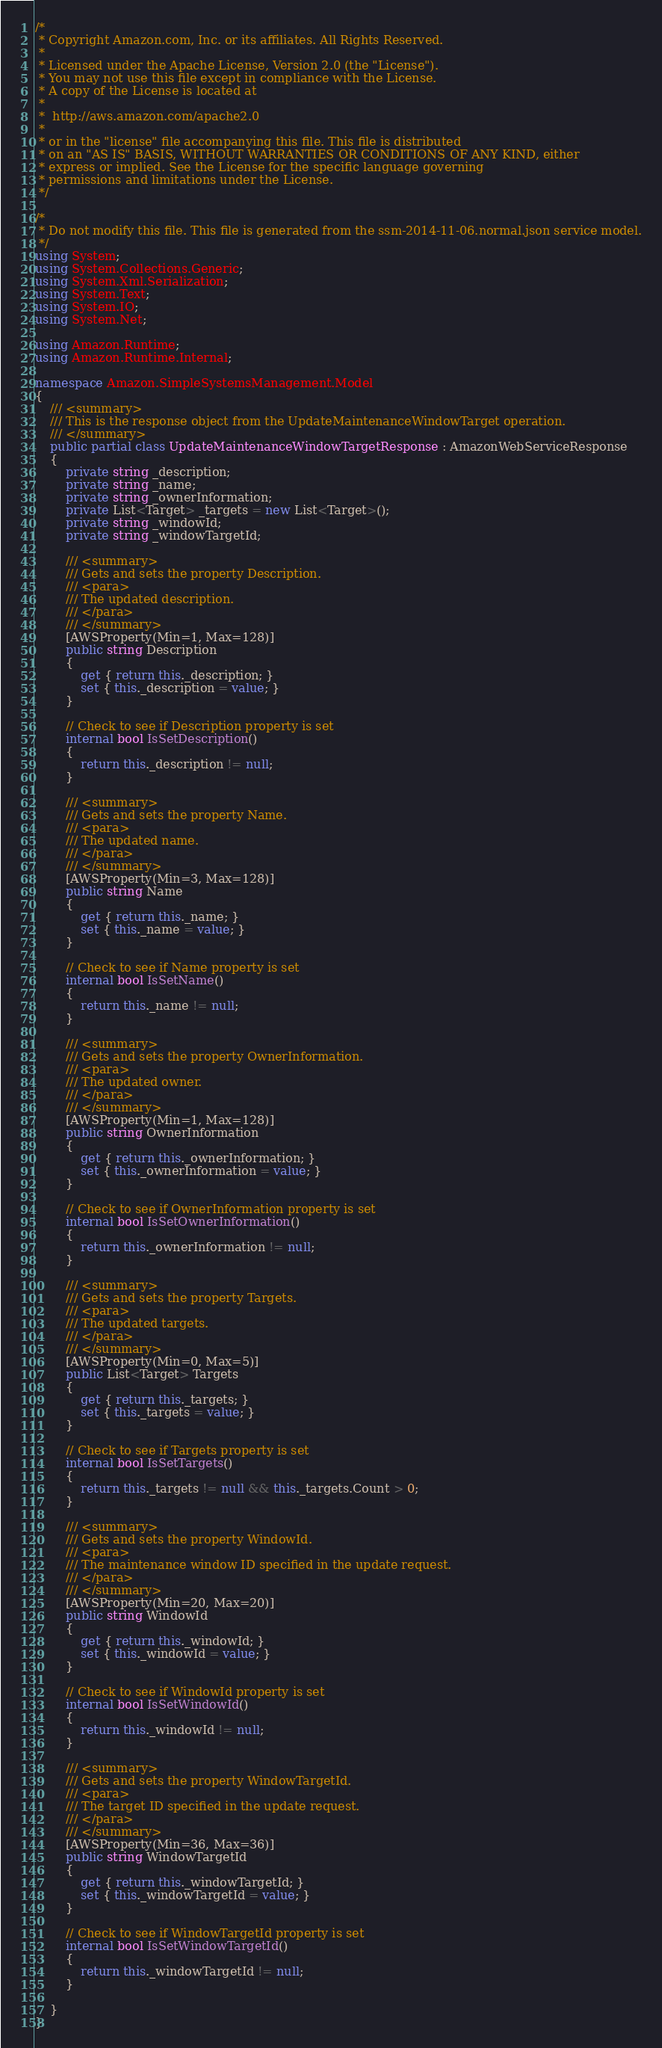<code> <loc_0><loc_0><loc_500><loc_500><_C#_>/*
 * Copyright Amazon.com, Inc. or its affiliates. All Rights Reserved.
 * 
 * Licensed under the Apache License, Version 2.0 (the "License").
 * You may not use this file except in compliance with the License.
 * A copy of the License is located at
 * 
 *  http://aws.amazon.com/apache2.0
 * 
 * or in the "license" file accompanying this file. This file is distributed
 * on an "AS IS" BASIS, WITHOUT WARRANTIES OR CONDITIONS OF ANY KIND, either
 * express or implied. See the License for the specific language governing
 * permissions and limitations under the License.
 */

/*
 * Do not modify this file. This file is generated from the ssm-2014-11-06.normal.json service model.
 */
using System;
using System.Collections.Generic;
using System.Xml.Serialization;
using System.Text;
using System.IO;
using System.Net;

using Amazon.Runtime;
using Amazon.Runtime.Internal;

namespace Amazon.SimpleSystemsManagement.Model
{
    /// <summary>
    /// This is the response object from the UpdateMaintenanceWindowTarget operation.
    /// </summary>
    public partial class UpdateMaintenanceWindowTargetResponse : AmazonWebServiceResponse
    {
        private string _description;
        private string _name;
        private string _ownerInformation;
        private List<Target> _targets = new List<Target>();
        private string _windowId;
        private string _windowTargetId;

        /// <summary>
        /// Gets and sets the property Description. 
        /// <para>
        /// The updated description.
        /// </para>
        /// </summary>
        [AWSProperty(Min=1, Max=128)]
        public string Description
        {
            get { return this._description; }
            set { this._description = value; }
        }

        // Check to see if Description property is set
        internal bool IsSetDescription()
        {
            return this._description != null;
        }

        /// <summary>
        /// Gets and sets the property Name. 
        /// <para>
        /// The updated name.
        /// </para>
        /// </summary>
        [AWSProperty(Min=3, Max=128)]
        public string Name
        {
            get { return this._name; }
            set { this._name = value; }
        }

        // Check to see if Name property is set
        internal bool IsSetName()
        {
            return this._name != null;
        }

        /// <summary>
        /// Gets and sets the property OwnerInformation. 
        /// <para>
        /// The updated owner.
        /// </para>
        /// </summary>
        [AWSProperty(Min=1, Max=128)]
        public string OwnerInformation
        {
            get { return this._ownerInformation; }
            set { this._ownerInformation = value; }
        }

        // Check to see if OwnerInformation property is set
        internal bool IsSetOwnerInformation()
        {
            return this._ownerInformation != null;
        }

        /// <summary>
        /// Gets and sets the property Targets. 
        /// <para>
        /// The updated targets.
        /// </para>
        /// </summary>
        [AWSProperty(Min=0, Max=5)]
        public List<Target> Targets
        {
            get { return this._targets; }
            set { this._targets = value; }
        }

        // Check to see if Targets property is set
        internal bool IsSetTargets()
        {
            return this._targets != null && this._targets.Count > 0; 
        }

        /// <summary>
        /// Gets and sets the property WindowId. 
        /// <para>
        /// The maintenance window ID specified in the update request.
        /// </para>
        /// </summary>
        [AWSProperty(Min=20, Max=20)]
        public string WindowId
        {
            get { return this._windowId; }
            set { this._windowId = value; }
        }

        // Check to see if WindowId property is set
        internal bool IsSetWindowId()
        {
            return this._windowId != null;
        }

        /// <summary>
        /// Gets and sets the property WindowTargetId. 
        /// <para>
        /// The target ID specified in the update request.
        /// </para>
        /// </summary>
        [AWSProperty(Min=36, Max=36)]
        public string WindowTargetId
        {
            get { return this._windowTargetId; }
            set { this._windowTargetId = value; }
        }

        // Check to see if WindowTargetId property is set
        internal bool IsSetWindowTargetId()
        {
            return this._windowTargetId != null;
        }

    }
}</code> 